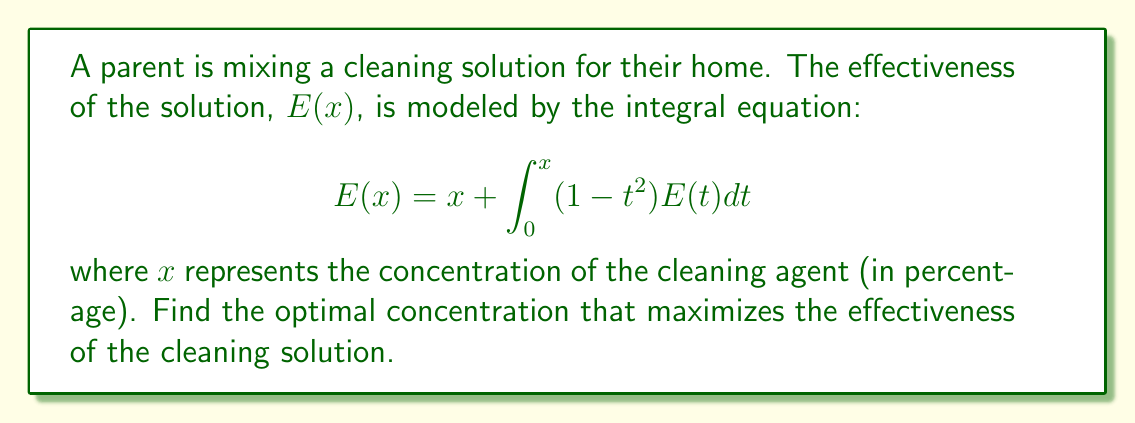Show me your answer to this math problem. To solve this integral equation and find the optimal concentration, we'll follow these steps:

1) First, we need to differentiate both sides of the equation with respect to $x$:

   $$\frac{d}{dx}E(x) = \frac{d}{dx}\left[x + \int_0^x (1 - t^2)E(t)dt\right]$$

2) Using the Fundamental Theorem of Calculus, we get:

   $$E'(x) = 1 + (1 - x^2)E(x)$$

3) Rearranging the terms:

   $$E'(x) - (1 - x^2)E(x) = 1$$

4) This is a first-order linear differential equation. We can solve it using an integrating factor:

   $$\mu(x) = e^{-\int (1-x^2)dx} = e^{-x+\frac{x^3}{3}}$$

5) Multiplying both sides by $\mu(x)$:

   $$e^{-x+\frac{x^3}{3}}E'(x) - e^{-x+\frac{x^3}{3}}(1-x^2)E(x) = e^{-x+\frac{x^3}{3}}$$

6) The left side is now the derivative of $e^{-x+\frac{x^3}{3}}E(x)$, so:

   $$\frac{d}{dx}\left(e^{-x+\frac{x^3}{3}}E(x)\right) = e^{-x+\frac{x^3}{3}}$$

7) Integrating both sides:

   $$e^{-x+\frac{x^3}{3}}E(x) = \int e^{-x+\frac{x^3}{3}}dx + C$$

8) The integral on the right side doesn't have an elementary antiderivative, but we can denote it as $F(x)$. So:

   $$E(x) = e^{x-\frac{x^3}{3}}(F(x) + C)$$

9) To find the optimal concentration, we need to maximize $E(x)$. This occurs when $E'(x) = 0$:

   $$E'(x) = e^{x-\frac{x^3}{3}}(F'(x) + (1-x^2)(F(x) + C)) = 0$$

10) This equation is satisfied when $1-x^2 = 0$, or $x = 1$.

Therefore, the optimal concentration is 1% (or 100% if we interpret $x$ as a decimal rather than a percentage).
Answer: 1% (or 100% if $x$ is interpreted as a decimal) 